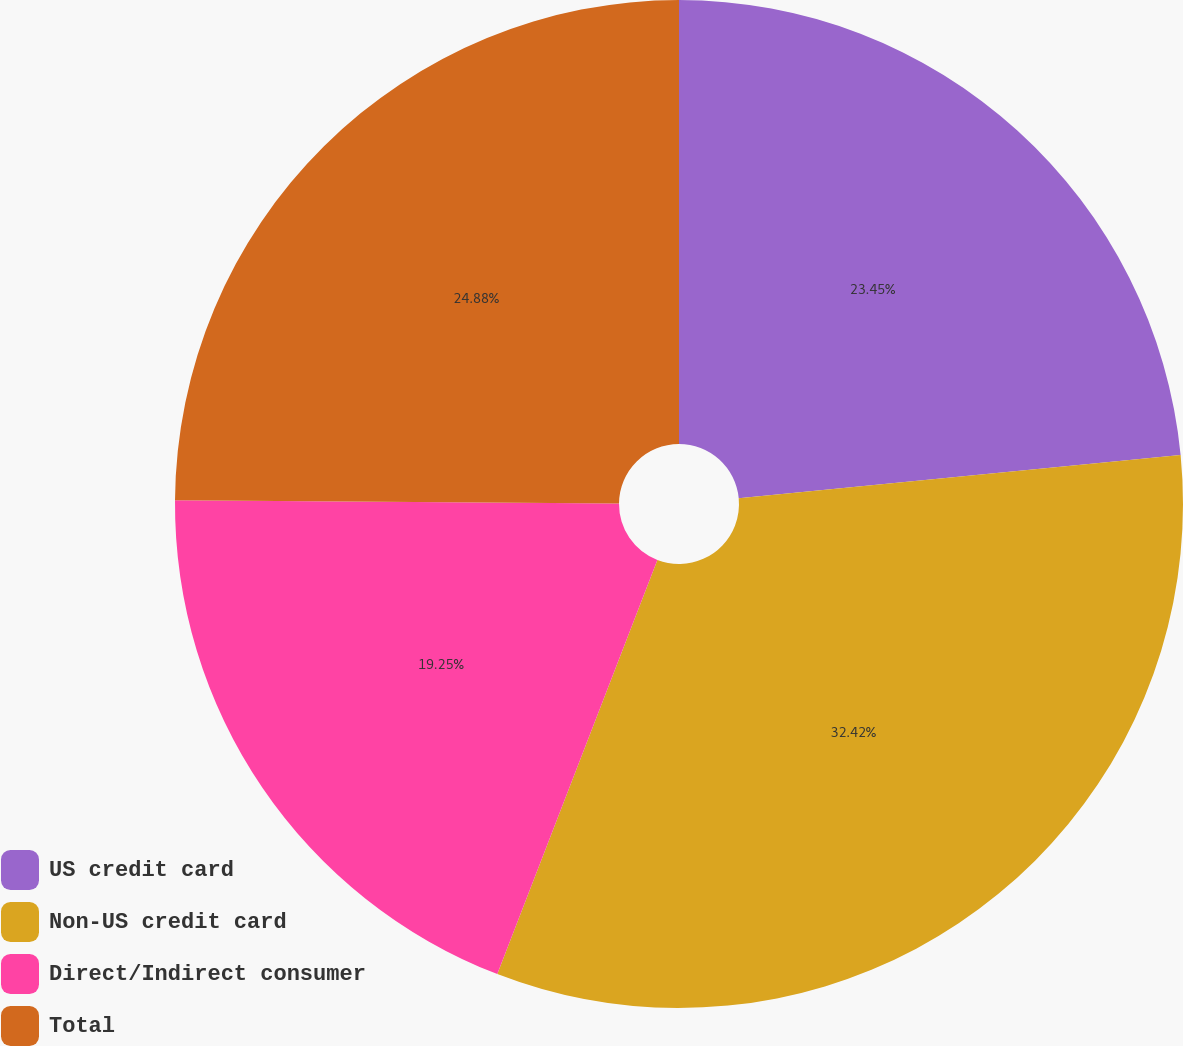Convert chart to OTSL. <chart><loc_0><loc_0><loc_500><loc_500><pie_chart><fcel>US credit card<fcel>Non-US credit card<fcel>Direct/Indirect consumer<fcel>Total<nl><fcel>23.45%<fcel>32.42%<fcel>19.25%<fcel>24.88%<nl></chart> 